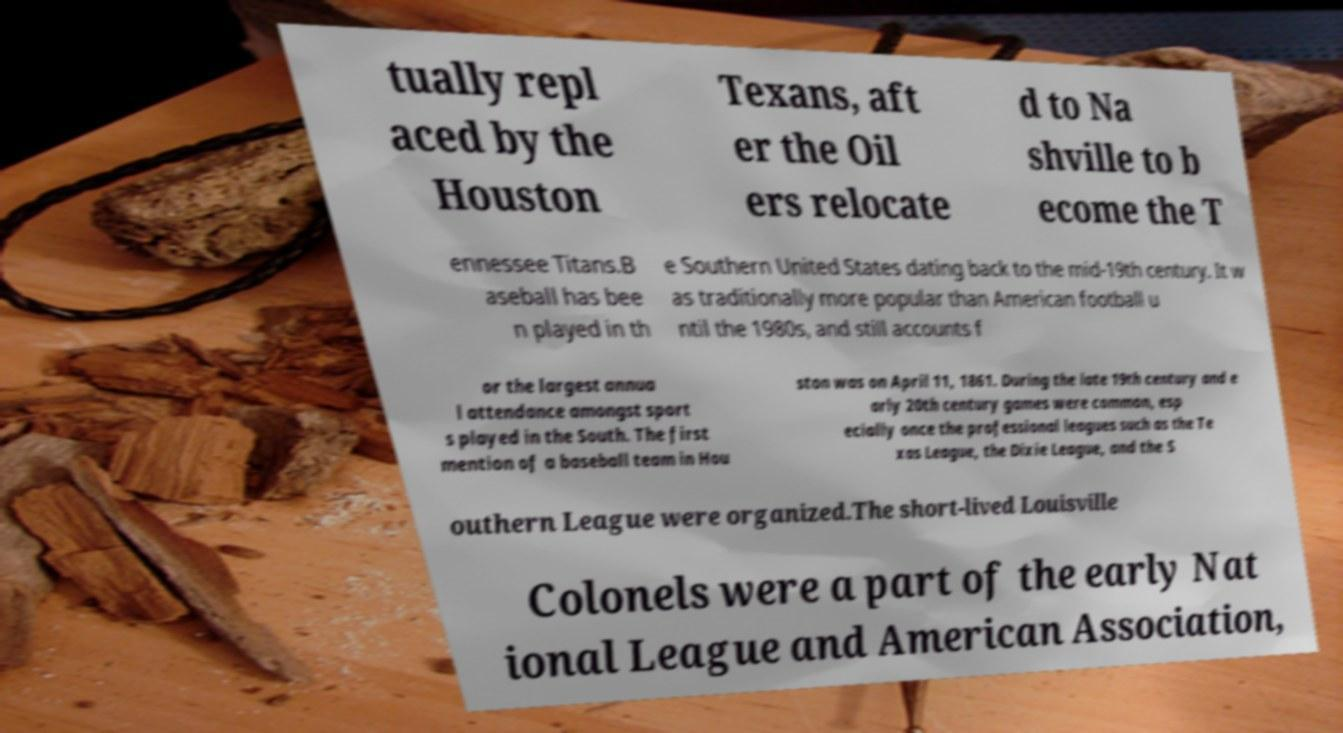There's text embedded in this image that I need extracted. Can you transcribe it verbatim? tually repl aced by the Houston Texans, aft er the Oil ers relocate d to Na shville to b ecome the T ennessee Titans.B aseball has bee n played in th e Southern United States dating back to the mid-19th century. It w as traditionally more popular than American football u ntil the 1980s, and still accounts f or the largest annua l attendance amongst sport s played in the South. The first mention of a baseball team in Hou ston was on April 11, 1861. During the late 19th century and e arly 20th century games were common, esp ecially once the professional leagues such as the Te xas League, the Dixie League, and the S outhern League were organized.The short-lived Louisville Colonels were a part of the early Nat ional League and American Association, 